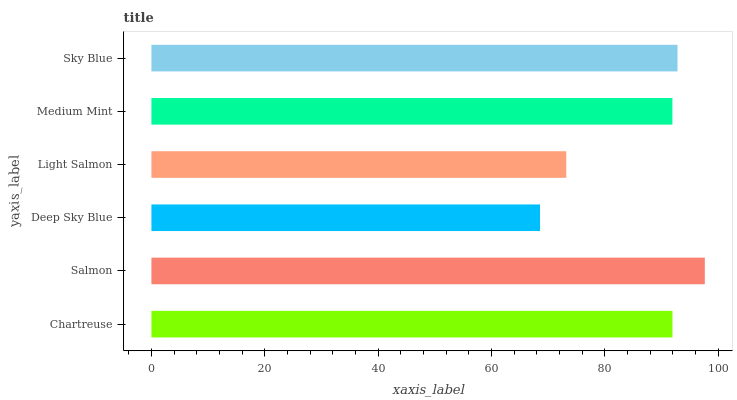Is Deep Sky Blue the minimum?
Answer yes or no. Yes. Is Salmon the maximum?
Answer yes or no. Yes. Is Salmon the minimum?
Answer yes or no. No. Is Deep Sky Blue the maximum?
Answer yes or no. No. Is Salmon greater than Deep Sky Blue?
Answer yes or no. Yes. Is Deep Sky Blue less than Salmon?
Answer yes or no. Yes. Is Deep Sky Blue greater than Salmon?
Answer yes or no. No. Is Salmon less than Deep Sky Blue?
Answer yes or no. No. Is Chartreuse the high median?
Answer yes or no. Yes. Is Medium Mint the low median?
Answer yes or no. Yes. Is Light Salmon the high median?
Answer yes or no. No. Is Salmon the low median?
Answer yes or no. No. 